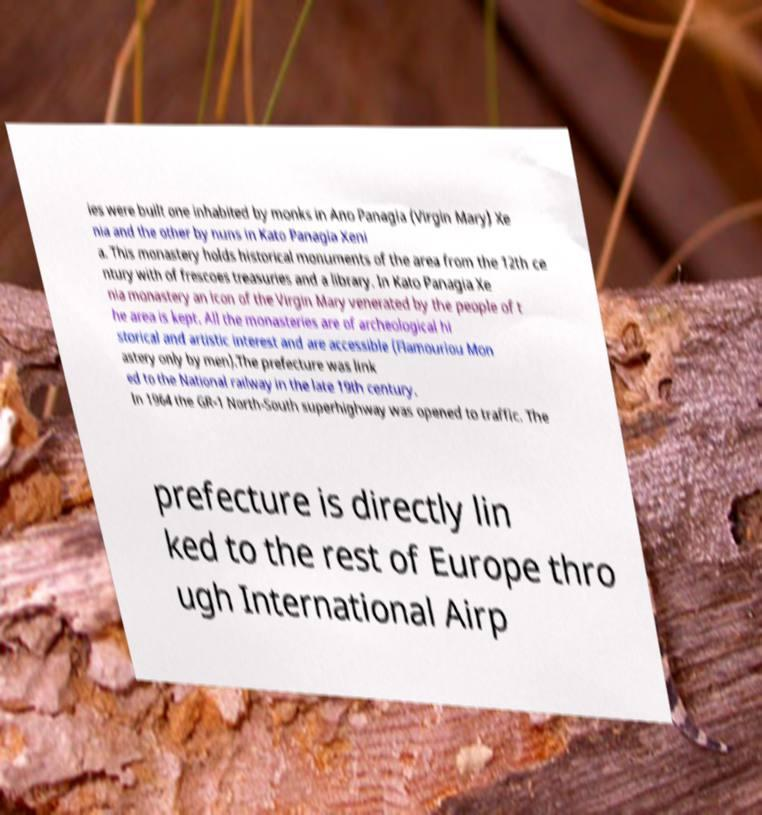What messages or text are displayed in this image? I need them in a readable, typed format. ies were built one inhabited by monks in Ano Panagia (Virgin Mary) Xe nia and the other by nuns in Kato Panagia Xeni a. This monastery holds historical monuments of the area from the 12th ce ntury with of frescoes treasuries and a library. In Kato Panagia Xe nia monastery an icon of the Virgin Mary venerated by the people of t he area is kept. All the monasteries are of archeological hi storical and artistic interest and are accessible (Flamouriou Mon astery only by men).The prefecture was link ed to the National railway in the late 19th century. In 1964 the GR-1 North-South superhighway was opened to traffic. The prefecture is directly lin ked to the rest of Europe thro ugh International Airp 